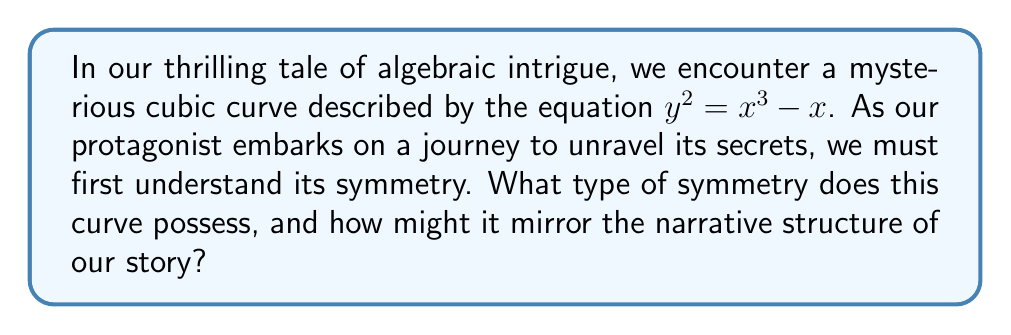Provide a solution to this math problem. Let us embark on this mathematical odyssey step by step:

1) First, we shall examine the curve's equation: $y^2 = x^3 - x$

2) To test for symmetry about the x-axis, we replace y with -y:
   $(-y)^2 = x^3 - x$
   $y^2 = x^3 - x$
   This is identical to our original equation, indicating symmetry about the x-axis.

3) To test for symmetry about the y-axis, we replace x with -x:
   $y^2 = (-x)^3 - (-x) = -x^3 + x$
   This is not equivalent to our original equation, so there's no symmetry about the y-axis.

4) However, if we negate both sides:
   $-y^2 = -(x^3 - x)$
   $y^2 = x^3 - x$
   This shows that the curve is invariant under the transformation $(x, y) \to (-x, iy)$, where $i$ is the imaginary unit.

5) Geometrically, this means the curve is symmetric about the origin if we rotate by 180° and then reflect across the x-axis.

6) In narrative terms, this symmetry mirrors a story structure where:
   - The x-axis symmetry represents parallel storylines or mirrored character arcs.
   - The origin symmetry under complex transformation symbolizes a dramatic reversal or twist at the story's midpoint.

[asy]
import graph;
size(200);
real f(real x) {return sqrt(x^3 - x);}
real g(real x) {return -sqrt(x^3 - x);}
draw(graph(f, -sqrt(2), sqrt(2)), blue);
draw(graph(g, -sqrt(2), sqrt(2)), blue);
xaxis("x");
yaxis("y");
[/asy]

This curve, known as the lemniscate of Bernoulli, encapsulates both symmetry and complexity, much like a well-crafted narrative.
Answer: The curve has x-axis symmetry and complex origin symmetry $(x, y) \to (-x, iy)$. 